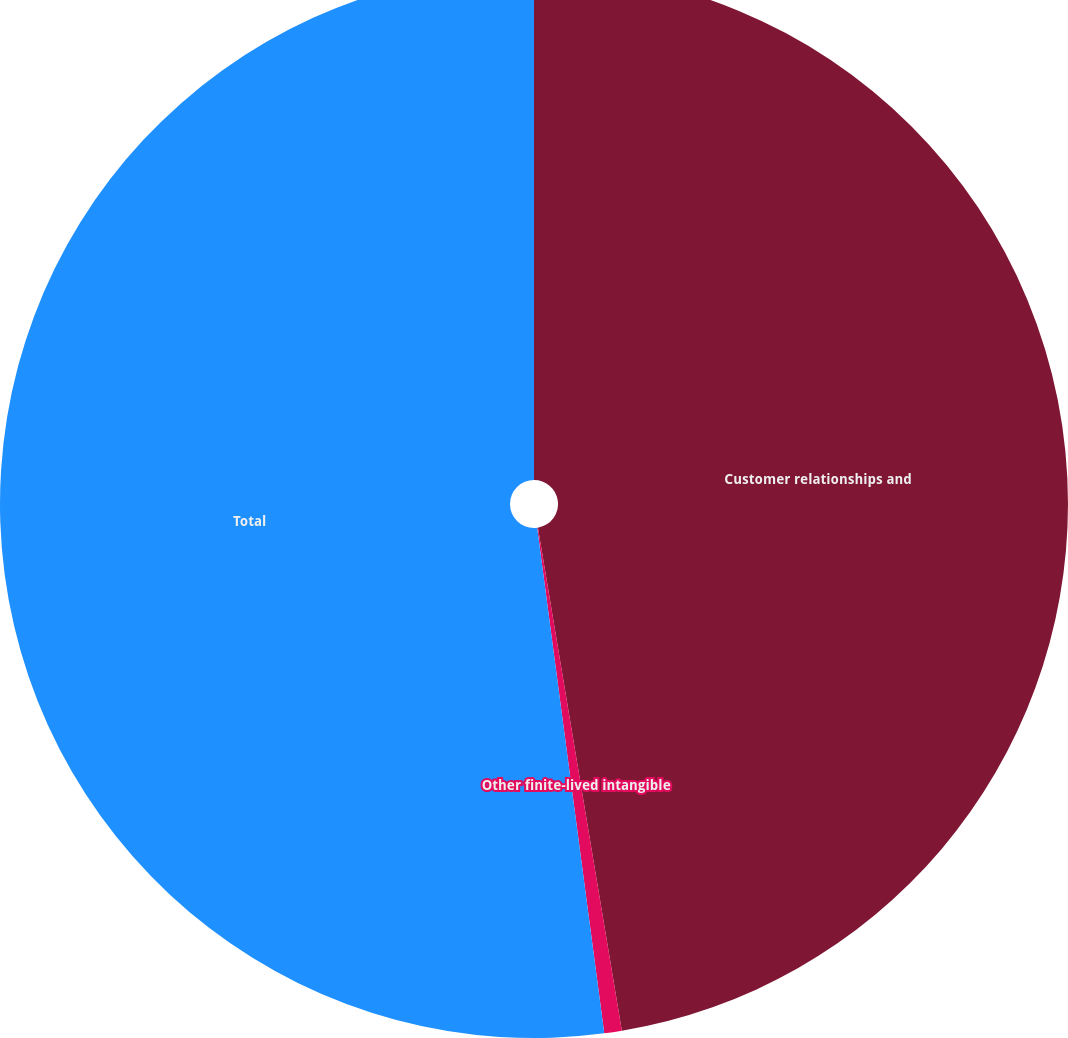Convert chart to OTSL. <chart><loc_0><loc_0><loc_500><loc_500><pie_chart><fcel>Customer relationships and<fcel>Other finite-lived intangible<fcel>Total<nl><fcel>47.37%<fcel>0.53%<fcel>52.1%<nl></chart> 